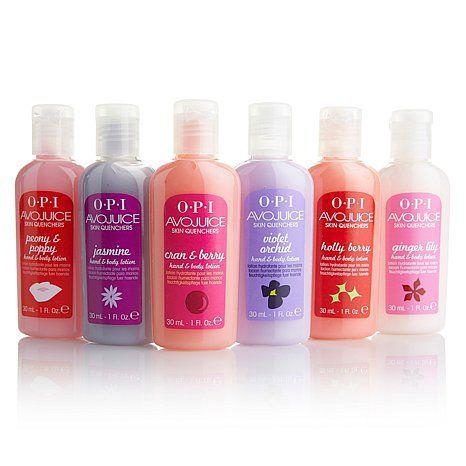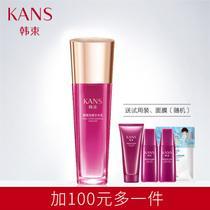The first image is the image on the left, the second image is the image on the right. Considering the images on both sides, is "At least one image features a single pump-top product." valid? Answer yes or no. No. 